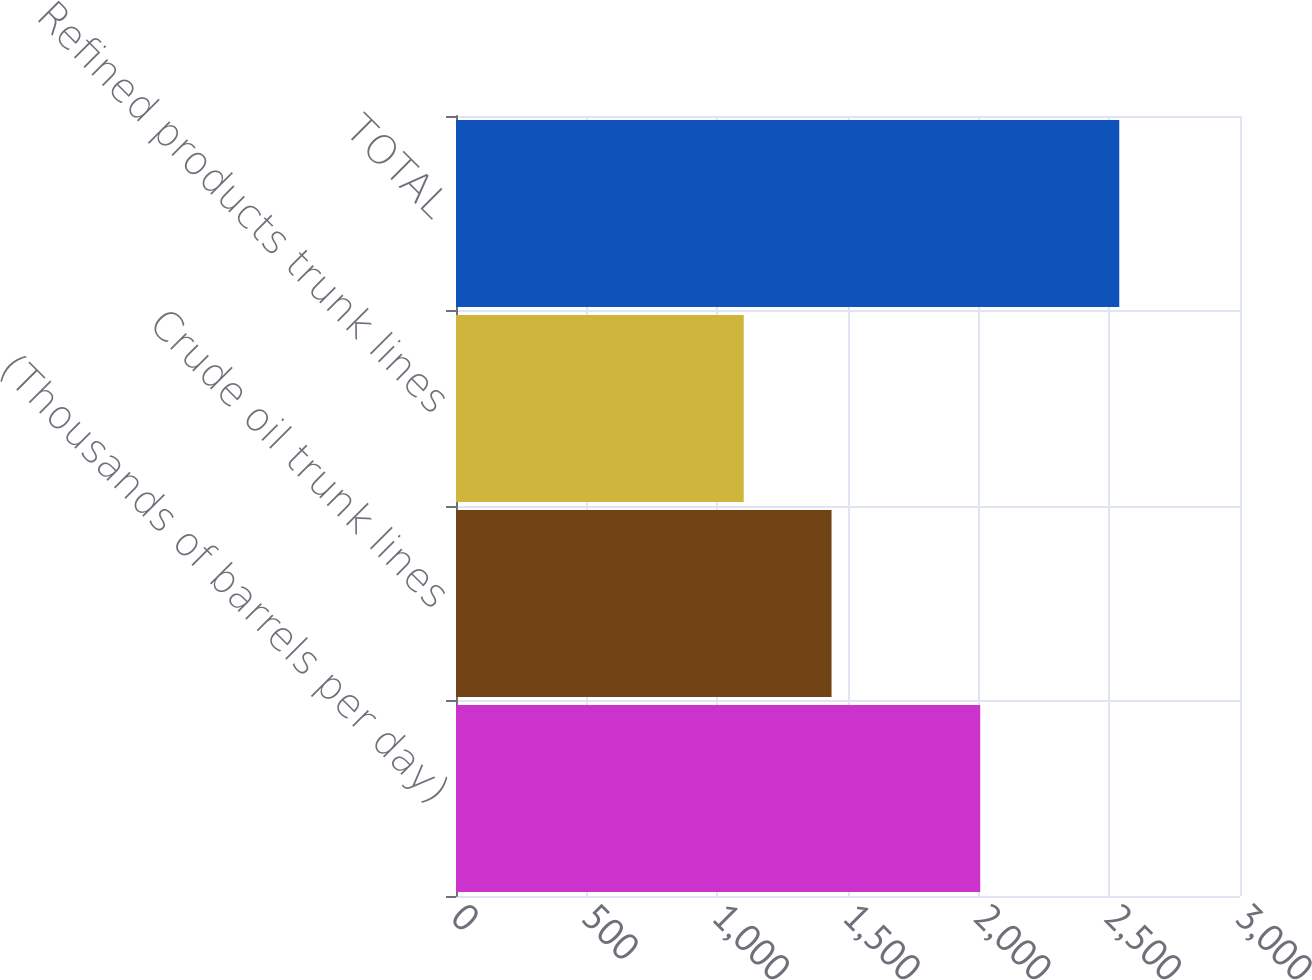Convert chart. <chart><loc_0><loc_0><loc_500><loc_500><bar_chart><fcel>(Thousands of barrels per day)<fcel>Crude oil trunk lines<fcel>Refined products trunk lines<fcel>TOTAL<nl><fcel>2006<fcel>1437<fcel>1101<fcel>2538<nl></chart> 